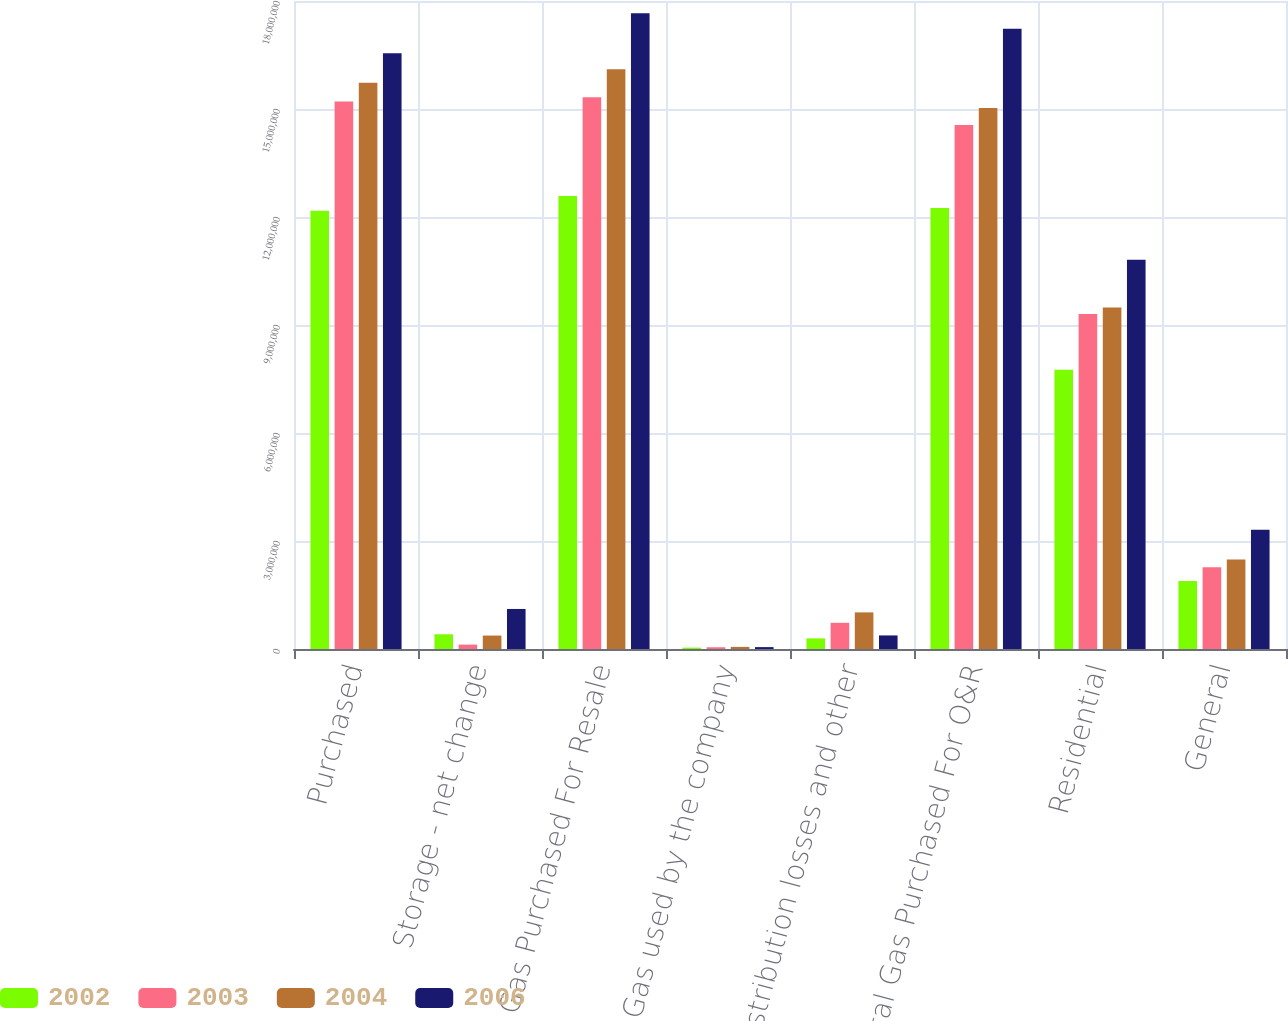<chart> <loc_0><loc_0><loc_500><loc_500><stacked_bar_chart><ecel><fcel>Purchased<fcel>Storage - net change<fcel>Gas Purchased For Resale<fcel>Less Gas used by the company<fcel>Distribution losses and other<fcel>Total Gas Purchased For O&R<fcel>Residential<fcel>General<nl><fcel>2002<fcel>1.2173e+07<fcel>409333<fcel>1.25824e+07<fcel>37630<fcel>294343<fcel>1.22504e+07<fcel>7.75844e+06<fcel>1.89156e+06<nl><fcel>2003<fcel>1.52083e+07<fcel>121547<fcel>1.53298e+07<fcel>48410<fcel>727243<fcel>1.45542e+07<fcel>9.30659e+06<fcel>2.26921e+06<nl><fcel>2004<fcel>1.57323e+07<fcel>373271<fcel>1.61056e+07<fcel>58823<fcel>1.01713e+06<fcel>1.50296e+07<fcel>9.48676e+06<fcel>2.4872e+06<nl><fcel>2006<fcel>1.65466e+07<fcel>1.11201e+06<fcel>1.76586e+07<fcel>52377<fcel>376605<fcel>1.72296e+07<fcel>1.08104e+07<fcel>3.31415e+06<nl></chart> 